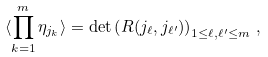<formula> <loc_0><loc_0><loc_500><loc_500>\langle \prod ^ { m } _ { k = 1 } \eta _ { j _ { k } } \rangle = \det \left ( R ( j _ { \ell } , j _ { \ell ^ { \prime } } ) \right ) _ { 1 \leq \ell , \ell ^ { \prime } \leq m } \, ,</formula> 